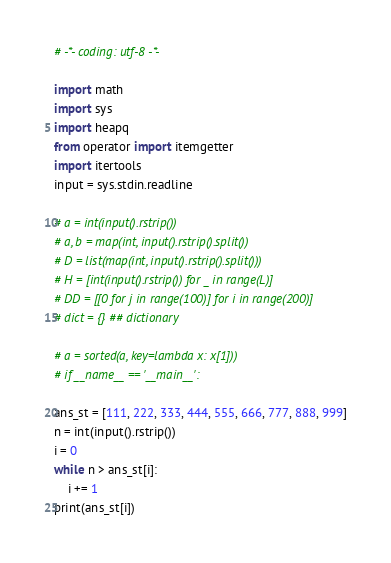Convert code to text. <code><loc_0><loc_0><loc_500><loc_500><_Python_># -*- coding: utf-8 -*-

import math
import sys
import heapq
from operator import itemgetter
import itertools
input = sys.stdin.readline

# a = int(input().rstrip())
# a, b = map(int, input().rstrip().split())
# D = list(map(int, input().rstrip().split()))
# H = [int(input().rstrip()) for _ in range(L)]
# DD = [[0 for j in range(100)] for i in range(200)]
# dict = {} ## dictionary

# a = sorted(a, key=lambda x: x[1]))
# if __name__ == '__main__':

ans_st = [111, 222, 333, 444, 555, 666, 777, 888, 999]
n = int(input().rstrip())
i = 0
while n > ans_st[i]:
	i += 1
print(ans_st[i])
</code> 